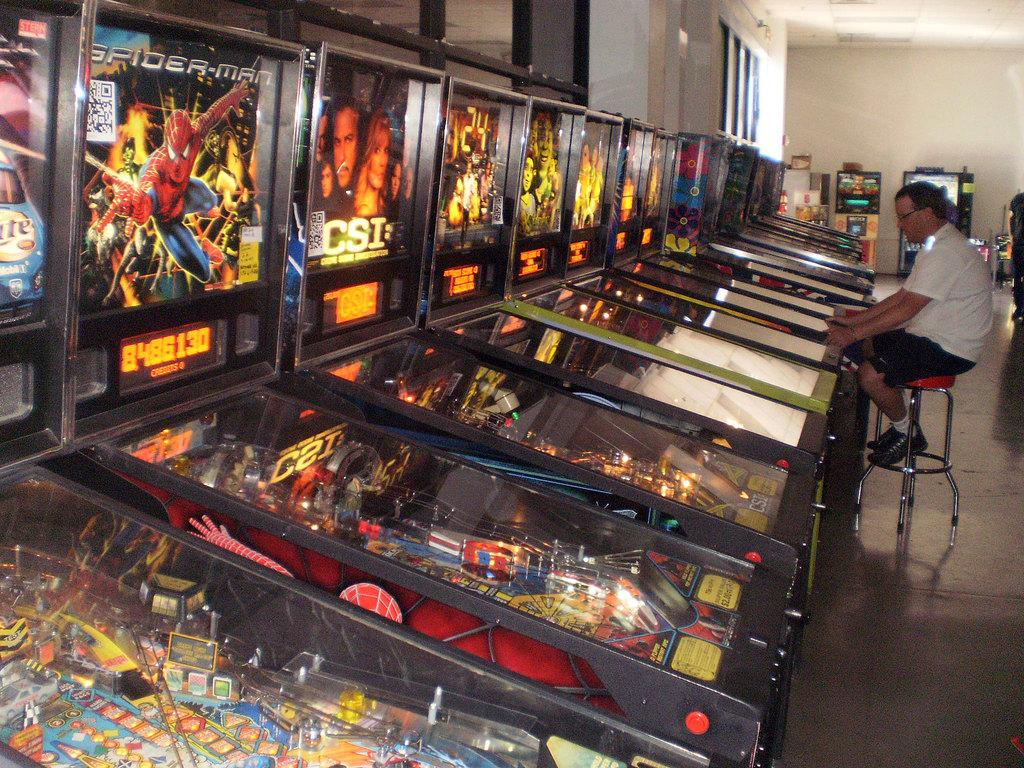What is the main subject of the image? The main subject of the image is many pinball machines. Can you describe the person in the image? There is a person wearing glasses in the image, and they are sitting on a stool. What is visible in the background of the image? There is a wall in the background of the image. How many tomatoes are on the pinball machines in the image? There are no tomatoes present in the image; it features pinball machines and a person wearing glasses. What type of key is used to operate the pinball machines in the image? There is no key visible in the image, and the operation of the pinball machines is not mentioned in the provided facts. 